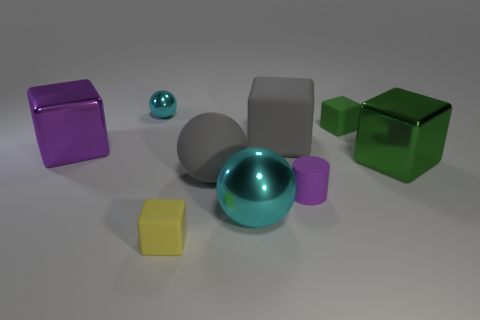Are there the same number of small purple rubber objects on the left side of the rubber sphere and big brown balls?
Your response must be concise. Yes. Is there anything else that is the same size as the yellow matte block?
Keep it short and to the point. Yes. There is another metal thing that is the same shape as the purple metal object; what is its color?
Keep it short and to the point. Green. How many big matte things have the same shape as the tiny green object?
Provide a short and direct response. 1. There is a large cube that is the same color as the matte sphere; what material is it?
Provide a succinct answer. Rubber. What number of tiny rubber objects are there?
Your answer should be compact. 3. Is there a big cyan sphere that has the same material as the purple cube?
Ensure brevity in your answer.  Yes. What size is the other metallic sphere that is the same color as the large metallic ball?
Your response must be concise. Small. There is a cyan object that is on the right side of the tiny yellow matte object; is its size the same as the shiny block on the left side of the gray matte block?
Your answer should be compact. Yes. What is the size of the cyan object behind the small purple matte object?
Give a very brief answer. Small. 